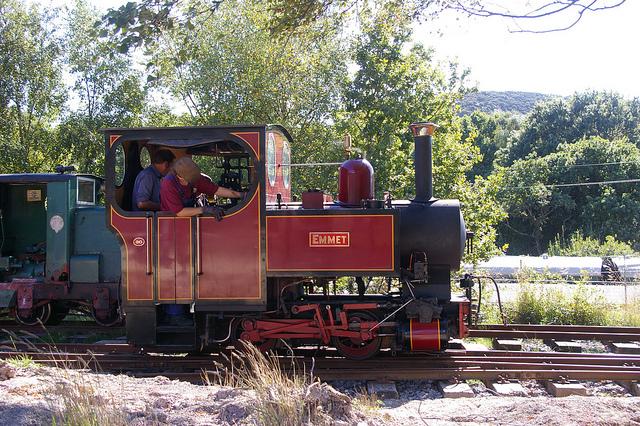Is this train functioning?
Answer briefly. Yes. Is this train attached to any cars?
Concise answer only. No. Does the train appear to be steam powered?
Give a very brief answer. Yes. 